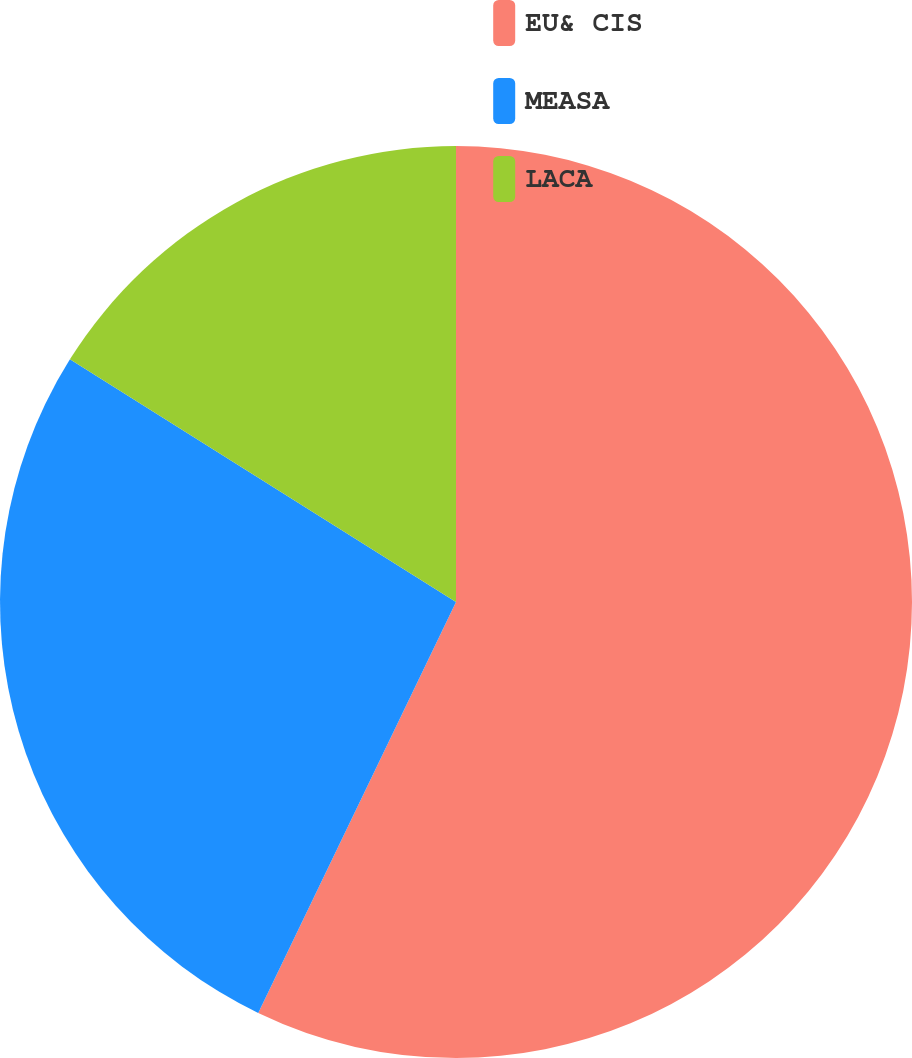<chart> <loc_0><loc_0><loc_500><loc_500><pie_chart><fcel>EU& CIS<fcel>MEASA<fcel>LACA<nl><fcel>57.14%<fcel>26.79%<fcel>16.07%<nl></chart> 